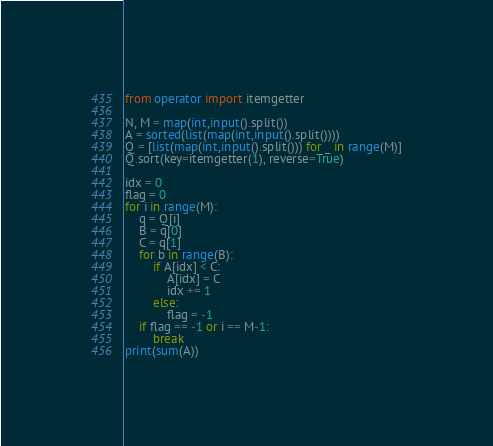Convert code to text. <code><loc_0><loc_0><loc_500><loc_500><_Python_>from operator import itemgetter

N, M = map(int,input().split())
A = sorted(list(map(int,input().split())))
Q = [list(map(int,input().split())) for _ in range(M)]
Q.sort(key=itemgetter(1), reverse=True)

idx = 0
flag = 0
for i in range(M):
    q = Q[i]
    B = q[0]
    C = q[1]
    for b in range(B):
        if A[idx] < C:
            A[idx] = C
            idx += 1
        else:
            flag = -1
    if flag == -1 or i == M-1:
        break
print(sum(A))
</code> 